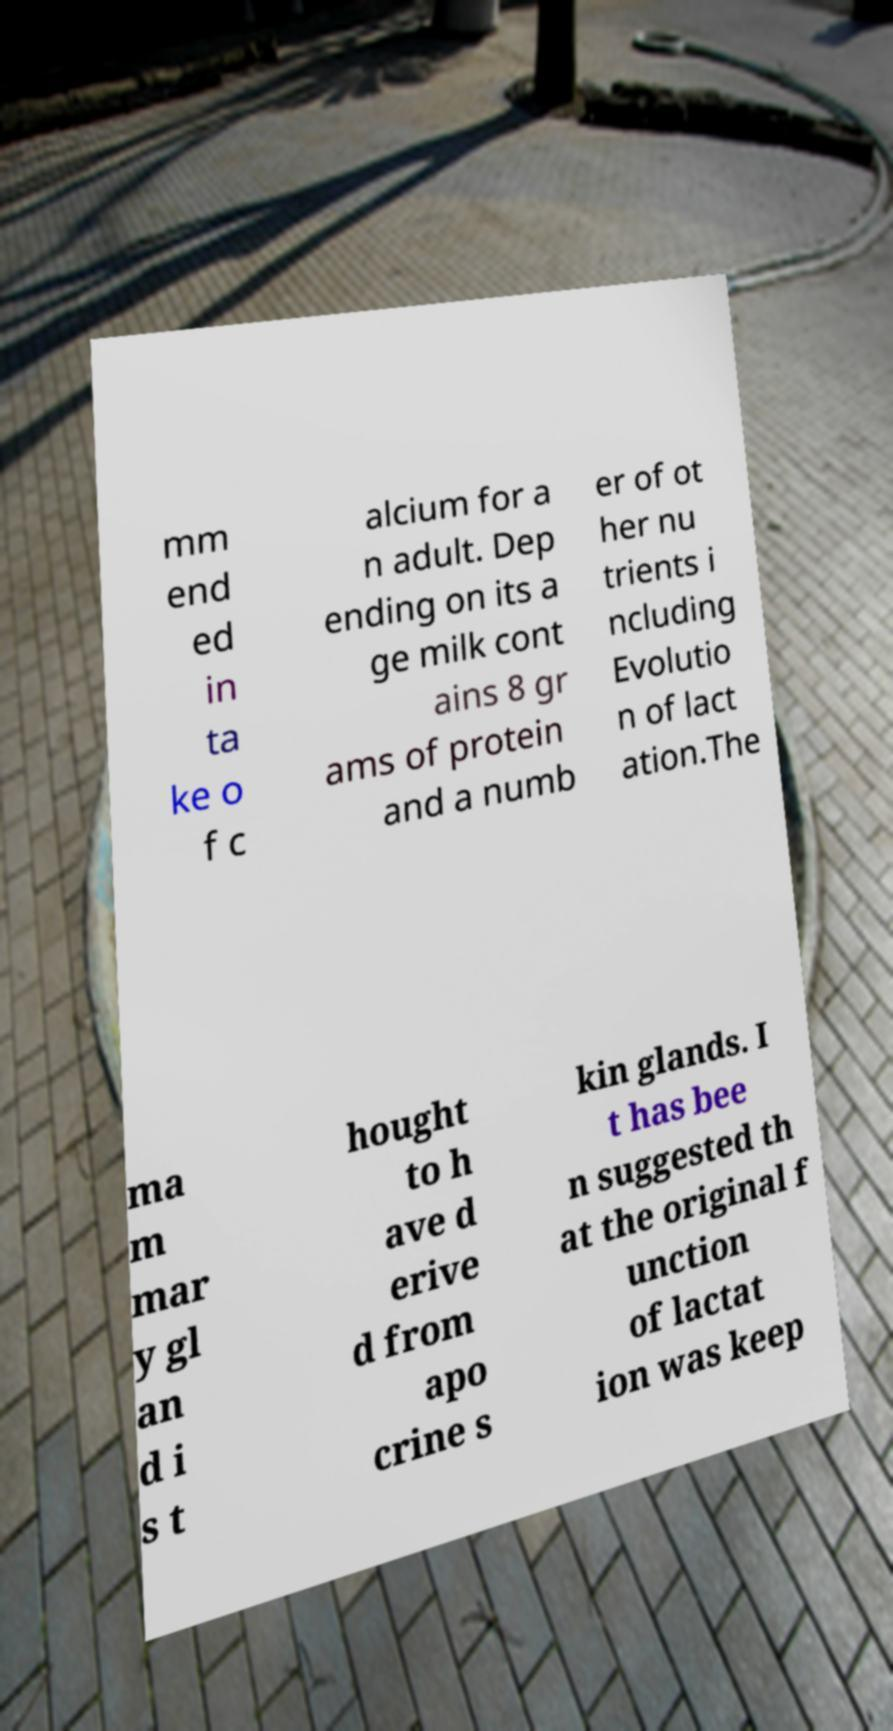Could you assist in decoding the text presented in this image and type it out clearly? mm end ed in ta ke o f c alcium for a n adult. Dep ending on its a ge milk cont ains 8 gr ams of protein and a numb er of ot her nu trients i ncluding Evolutio n of lact ation.The ma m mar y gl an d i s t hought to h ave d erive d from apo crine s kin glands. I t has bee n suggested th at the original f unction of lactat ion was keep 